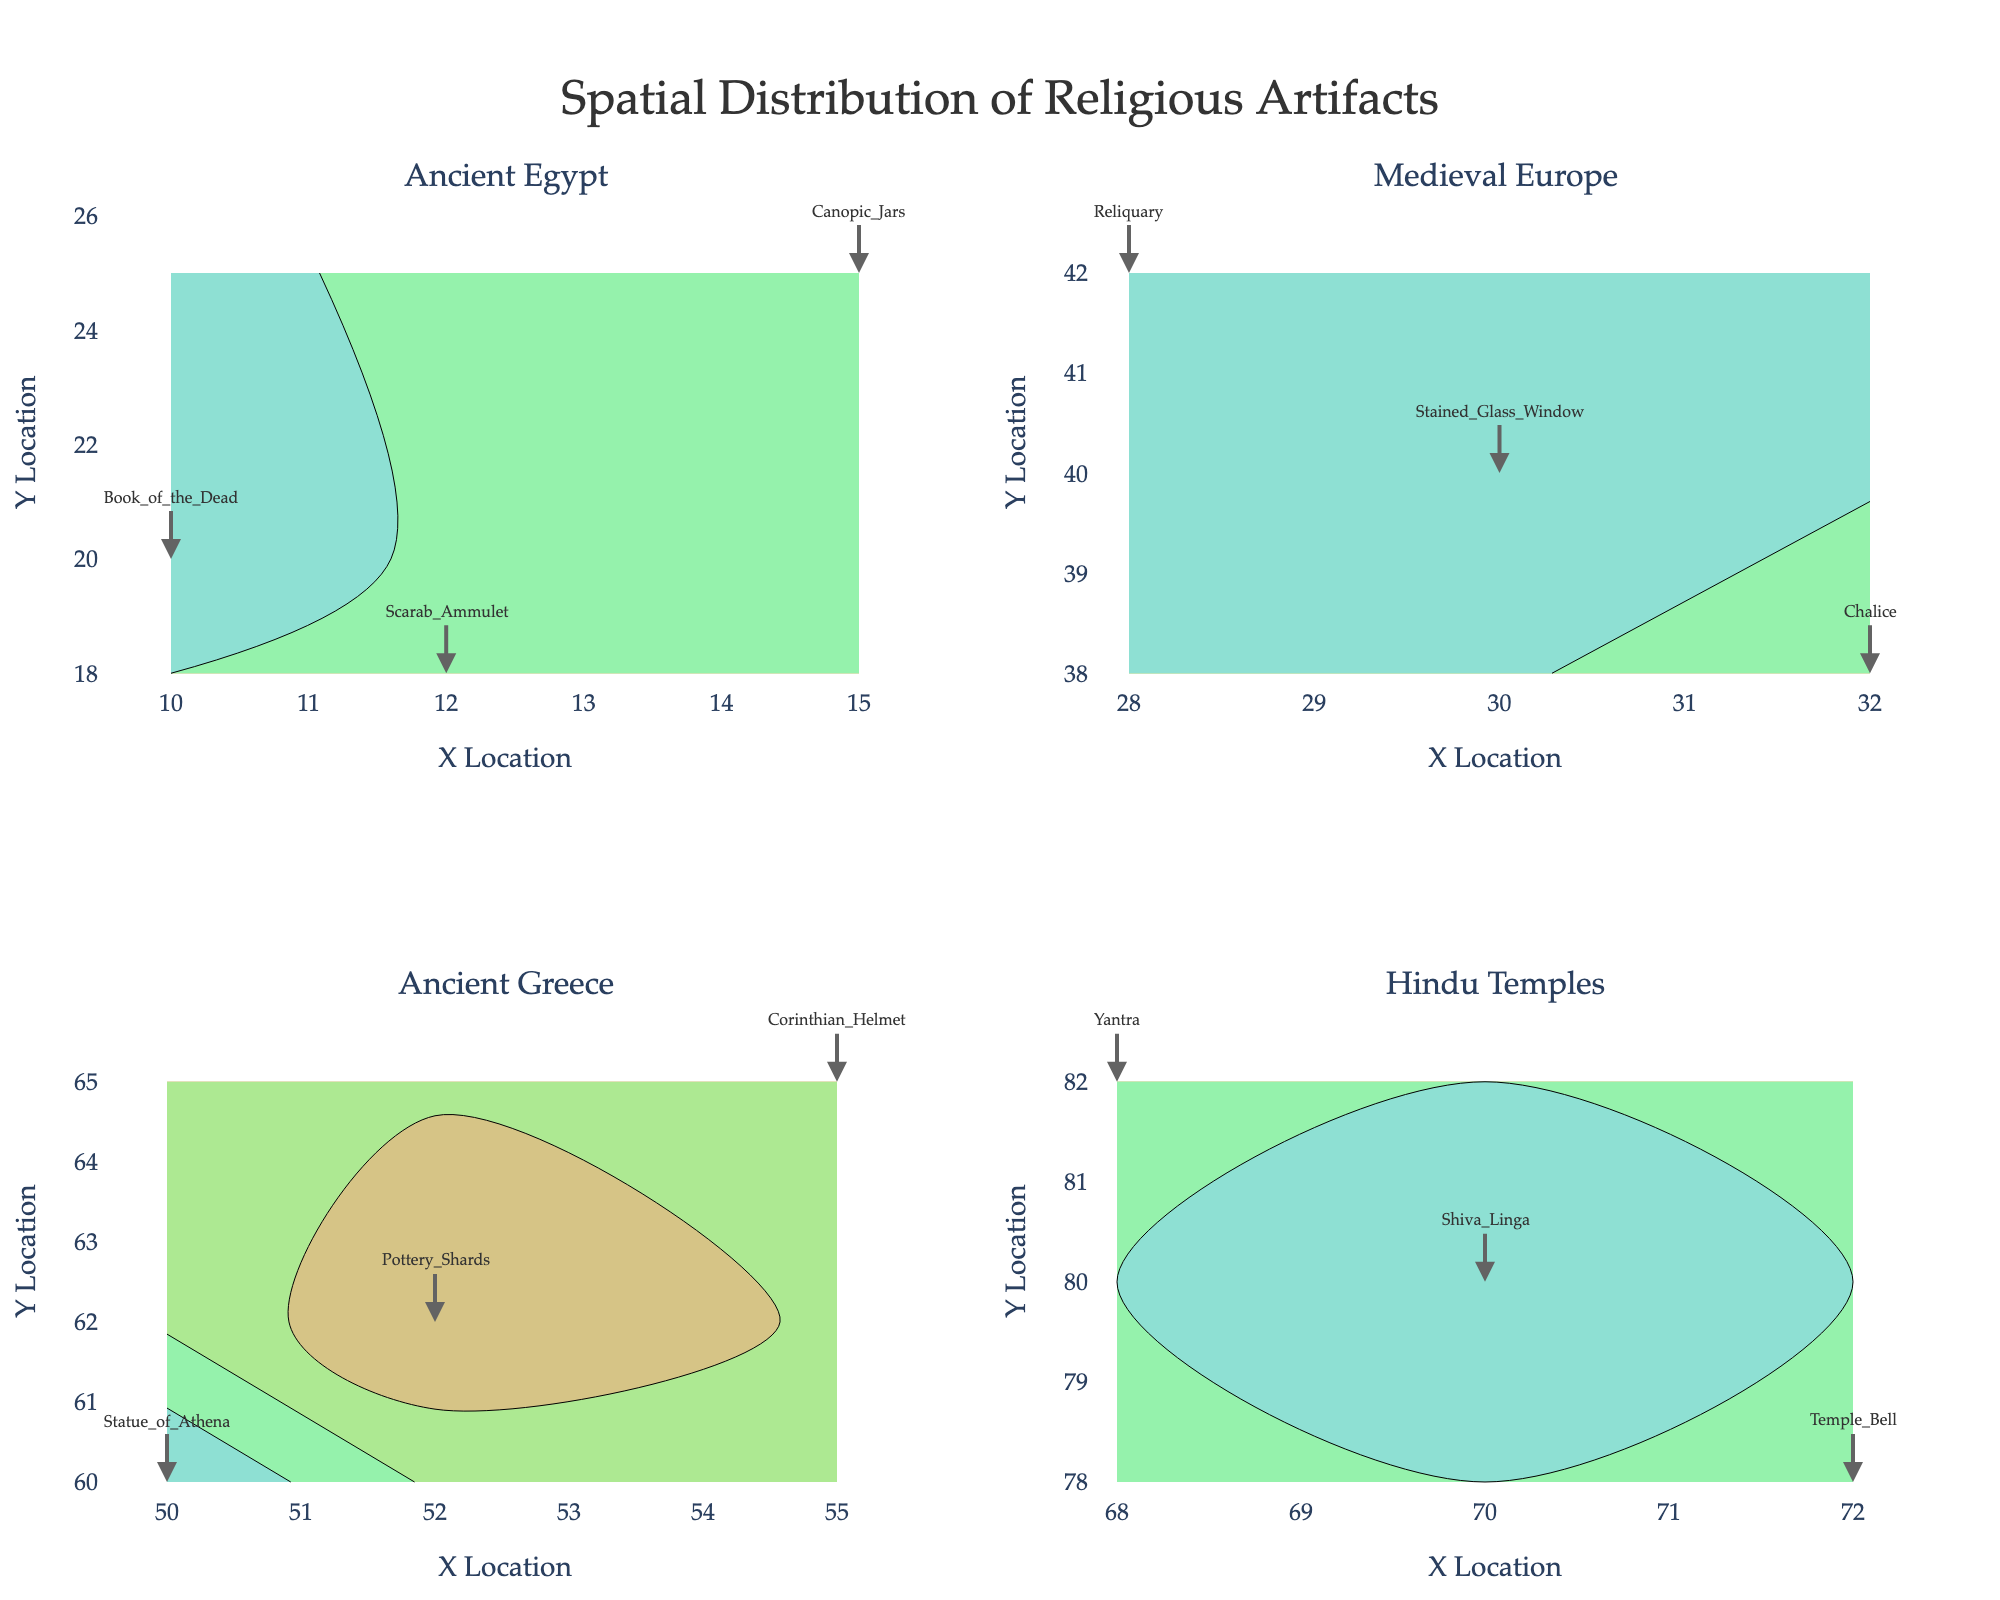In which subplot can you find the icon of the Virgin Mary? The subplots are titled "Ancient Egypt," "Medieval Europe," "Ancient Greece," and "Hindu Temples." The "Icon of the Virgin Mary" is under the "Byzantine Empire" cultural area, which is not one of the given subplot titles.
Answer: None How many artifacts have a "High" significance level in the Medieval Europe subplot? The Medieval Europe subplot is located in the top right. The artifacts with "High" significance in this subplot are "Stained Glass Window" and "Reliquary." Counting them gives us 2.
Answer: 2 Which artifact is located at (72, 78)? By looking at the coordinates in the subplots, the artifact at (72, 78) is in the "Hindu Temples" subplot and is identified as "Temple Bell."
Answer: Temple Bell Comparing the Ancient Egypt and Ancient Greece subplots, which has more artifacts with a "Medium" significance level? Ancient Egypt has "Canopic Jars" and "Scarab Amulet" with medium significance. Ancient Greece has "Corinthian Helmet" and "Yantra" with medium significance. Both subplots have the same number of artifacts with medium significance, which is 2.
Answer: Both have 2 What is the spatial distribution pattern observed in the Hindu Temples subplot? The artifacts in the Hindu Temples subplot are clustered around coordinates (70, 80) with "High" significance at (70, 80) and "Medium" significance artifacts surrounding it. This suggests a central artifact with significant ones nearby.
Answer: Clustered around (70, 80) with central high significance Which subplot has the widest distribution of artifact coordinates? Comparatively, the coordinates in the "Byzantine Empire" subplot range from (85, 105) to (90, 100), indicating a dense and slightly  wider spread compared to the other subplots.
Answer: Byzantine Empire In the "Ancient Greece" subplot, which artifact has the lowest significance level? Look at the "Ancient Greece" subplot and verify that the "Pottery Shards" is marked with "Low" significance.
Answer: Pottery Shards Are there any cultural areas where all artifacts have a high significance level? By examining all subplots, it's seen that not all artifacts within any single cultural area have exclusively high significance levels. Some have medium and low significance levels as well.
Answer: No How many artifacts are displayed in the entire plot? Counting all the artifacts listed, we see the plot includes 15 artifacts distributed across various subplots.
Answer: 15 